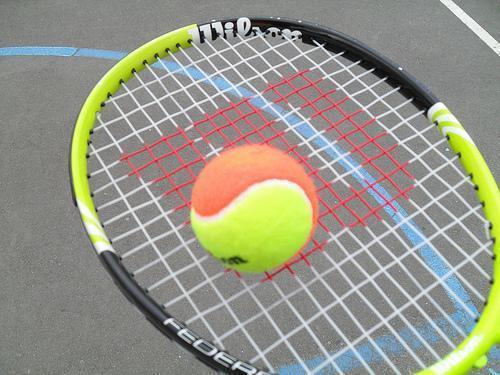How many balls are there?
Give a very brief answer. 1. 